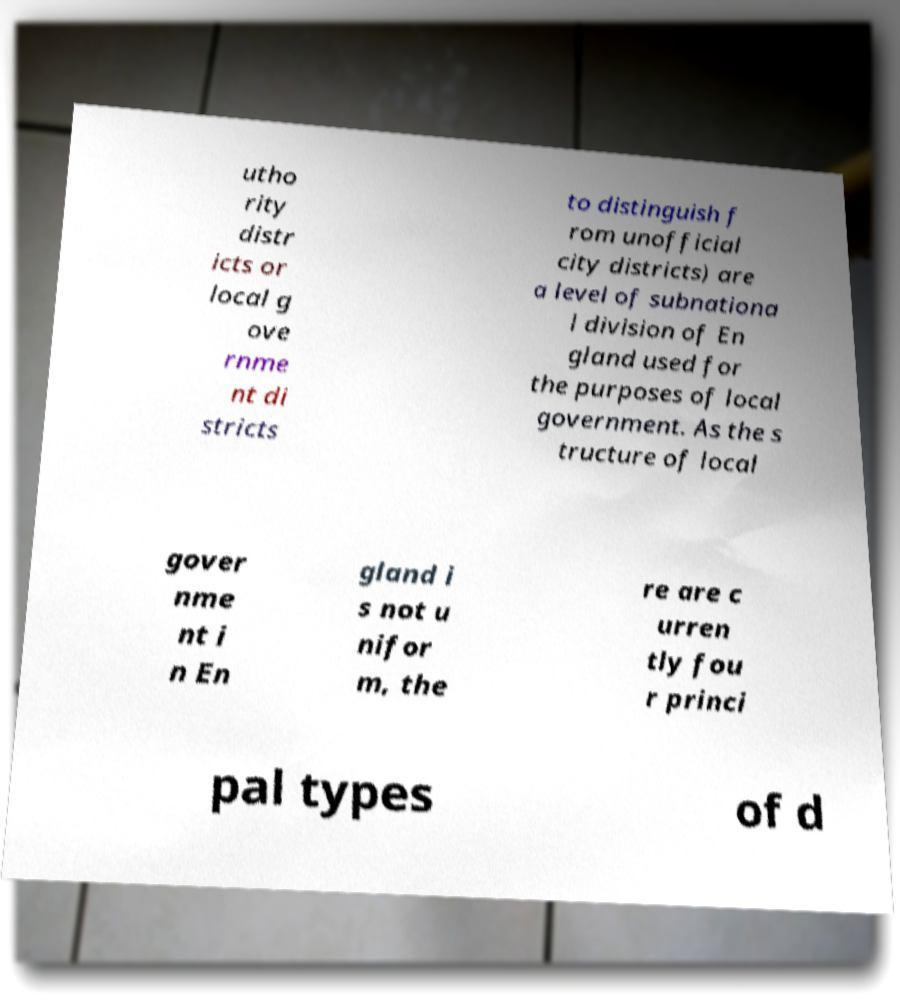There's text embedded in this image that I need extracted. Can you transcribe it verbatim? utho rity distr icts or local g ove rnme nt di stricts to distinguish f rom unofficial city districts) are a level of subnationa l division of En gland used for the purposes of local government. As the s tructure of local gover nme nt i n En gland i s not u nifor m, the re are c urren tly fou r princi pal types of d 